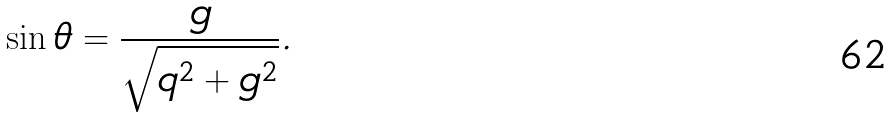Convert formula to latex. <formula><loc_0><loc_0><loc_500><loc_500>\sin { \theta } = \frac { g } { \sqrt { q ^ { 2 } + g ^ { 2 } } } .</formula> 